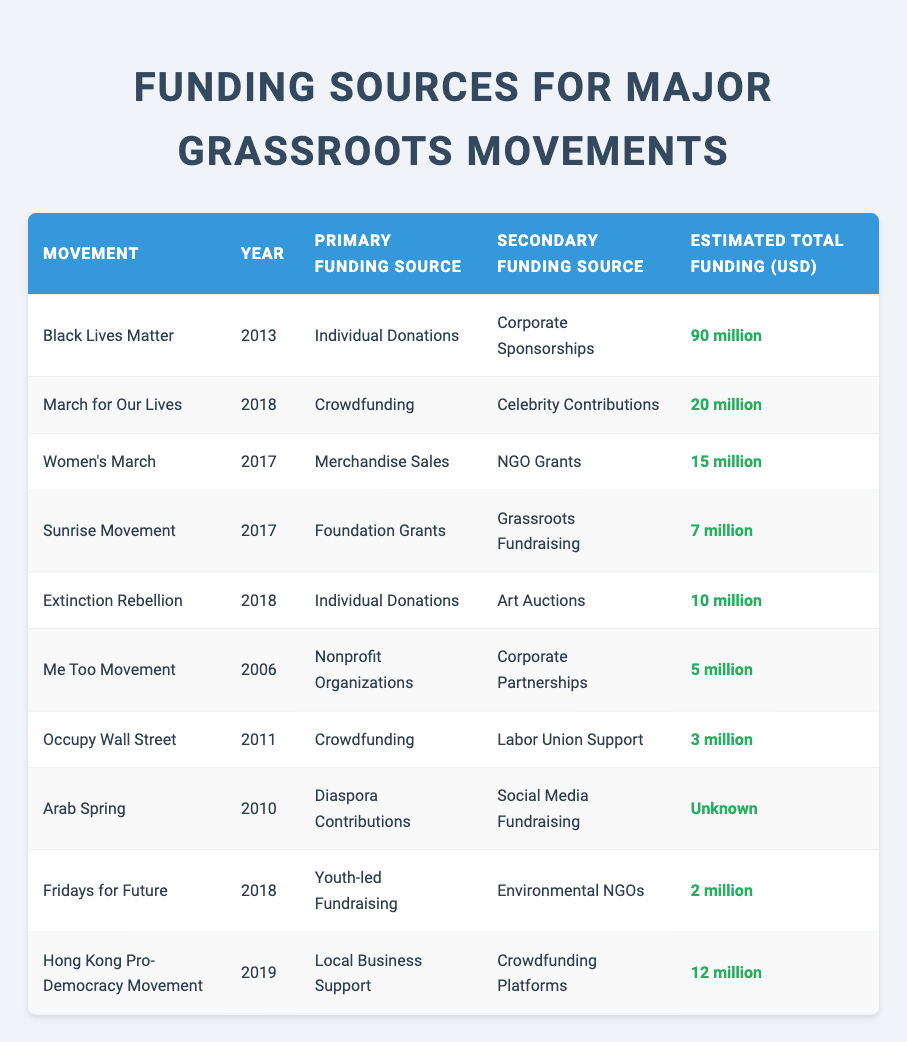What was the estimated total funding for the Black Lives Matter movement? The table lists the estimated total funding for the Black Lives Matter movement in the row corresponding to its name. According to that row, the estimated total funding for the movement is 90 million USD.
Answer: 90 million Which movement had a primary funding source of crowdfunding in 2018? The table shows multiple movements and their funding sources. By scanning the table, I can see that the March for Our Lives movement listed in the 2018 row has crowdfunding as its primary funding source.
Answer: March for Our Lives What was the secondary funding source for the Women's March? Looking at the row for the Women's March, I see that the secondary funding source listed is NGO grants.
Answer: NGO Grants Which two movements had their estimated total funding between 7 million and 12 million? I examine the total funding amounts for each movement listed in the table. The movements Sunrise Movement (7 million) and Hong Kong Pro-Democracy Movement (12 million) both have estimated total funding within that range.
Answer: Sunrise Movement and Hong Kong Pro-Democracy Movement Is it true that the Extinction Rebellion movement had more funding from individual donations than the Women's March? I compare the funding sources for both movements. The Extinction Rebellion listed individual donations as its primary funding source with 10 million total funding, while the Women's March did not list individual donations as a source and had lower total funding of 15 million. Therefore, it is false that Extinction Rebellion had more from individual donations since the Women’s March does not list it at all.
Answer: No Which funding sources were used by the Fridays for Future movement? Referring to the row that corresponds to the Fridays for Future movement, I observe that the primary funding source is youth-led fundraising and the secondary source is environmental NGOs.
Answer: Youth-led Fundraising and Environmental NGOs What is the average estimated total funding among the movements that received funding from crowdfunding? To find the average estimated total funding for movements funded by crowdfunding, I identify the movements: March for Our Lives (20 million), Occupy Wall Street (3 million), and Extinction Rebellion (10 million). Adding these gives 20 + 3 + 10 = 33 million. Dividing by the number of movements gives 33/3 = 11 million as the average.
Answer: 11 million Was the Arab Spring movement funded more than the Hong Kong Pro-Democracy Movement? By comparing the two movements, the Arab Spring has an 'unknown' funding amount while the Hong Kong Pro-Democracy Movement is listed as 12 million. Since 'unknown' cannot be quantified as more, it leads to the conclusion that we cannot assert the Arab Spring had more funding.
Answer: No What is the total funding of the Me Too movement compared to the estimated funding of the Sunrise Movement? The total funding for the Me Too movement is listed as 5 million, while the Sunrise Movement's total funding is 7 million. Comparing these two, 7 million is greater than 5 million, indicating the Sunrise Movement has a higher total funding.
Answer: Sunrise Movement has more funding 